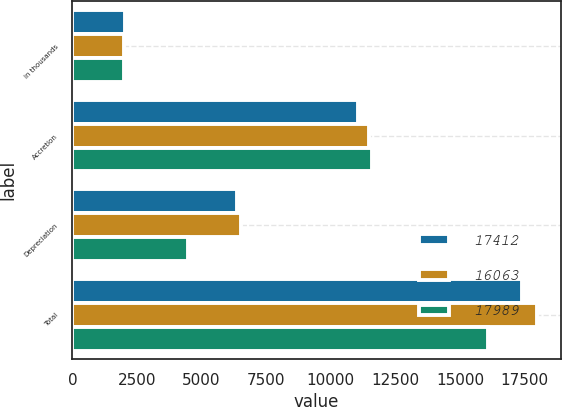<chart> <loc_0><loc_0><loc_500><loc_500><stacked_bar_chart><ecel><fcel>in thousands<fcel>Accretion<fcel>Depreciation<fcel>Total<nl><fcel>17412<fcel>2016<fcel>11059<fcel>6353<fcel>17412<nl><fcel>16063<fcel>2015<fcel>11474<fcel>6515<fcel>17989<nl><fcel>17989<fcel>2014<fcel>11601<fcel>4462<fcel>16063<nl></chart> 